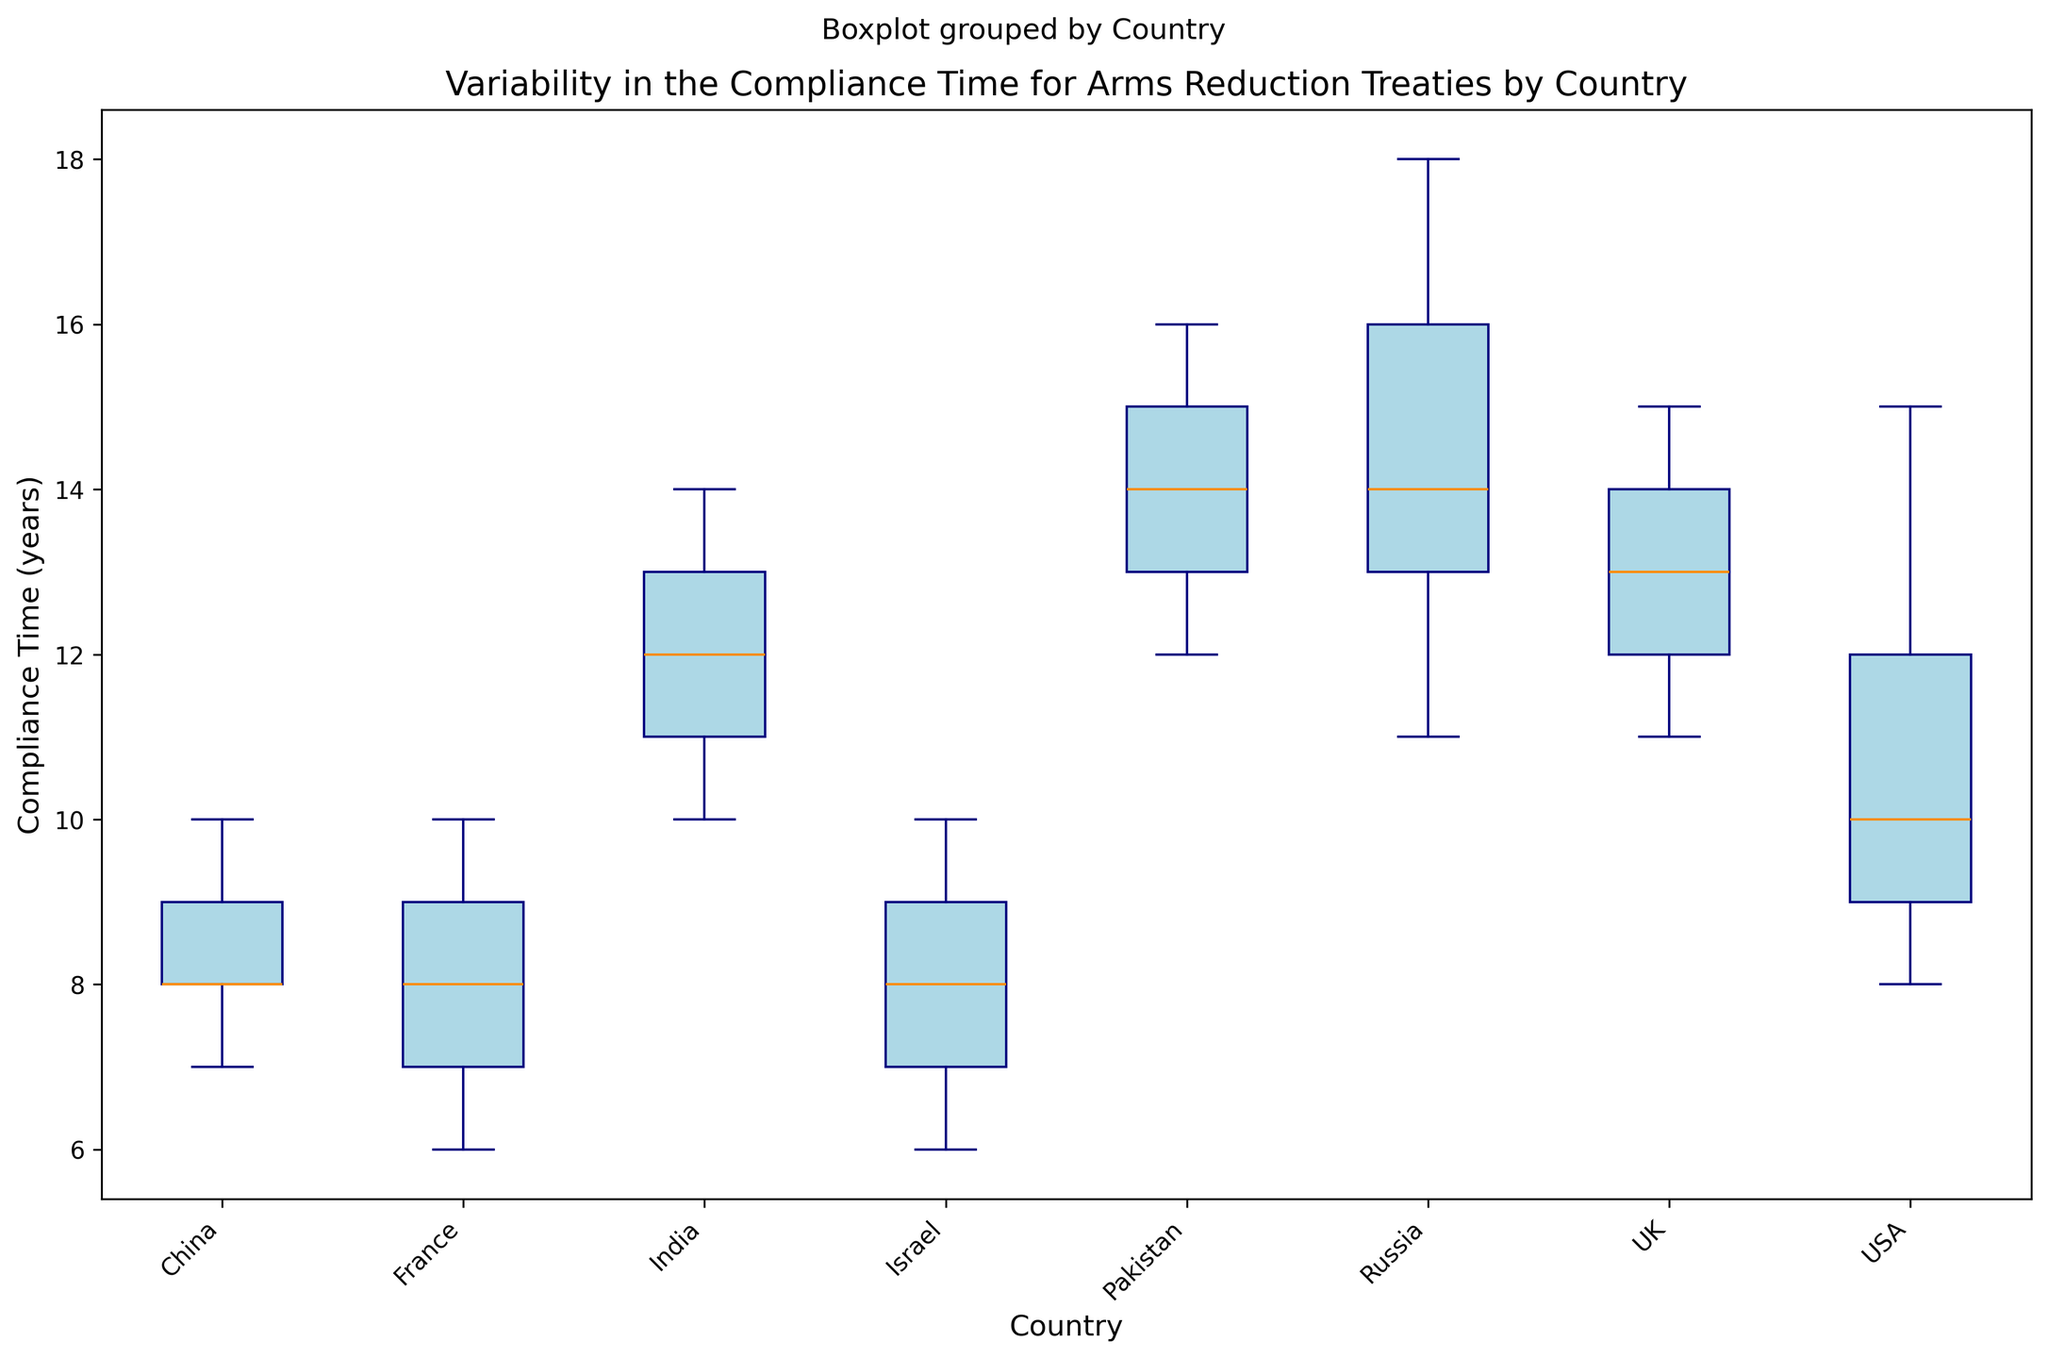What's the median compliance time for China? To find the median compliance time for China, look at the middle value of its sorted compliance times (7, 8, 8, 9, 10). The median is 8.
Answer: 8 Which country has the largest range in compliance time? The range is the difference between the maximum and minimum values. USA (15-8=7), Russia (18-11=7), China (10-7=3), UK (15-11=4), France (10-6=4), India (14-10=4), Pakistan (16-12=4), and Israel (10-6=4). Both USA and Russia have the largest range at 7 years.
Answer: USA and Russia Which country has the smallest interquartile range (IQR)? IQR is the difference between the third quartile (Q3) and the first quartile (Q1). Visually compare the widths of the boxes in the plot. The smallest IQR corresponds to the narrowest box. Israel's box is the narrowest, indicating the smallest IQR.
Answer: Israel What is the median compliance time for the USA compared to France? Identify the median lines in the USA and France boxes. The USA median is around 10 years, while France's is 8 years. The USA has a higher median compliance time.
Answer: USA has a higher median compliance time Describe the variability in compliance time for India's compliance compared to the UK? Observe the whiskers and the spread of the boxes. Both the UK and India have similar ranges and IQR, but India's variability is slightly higher due to whiskers extending a bit more.
Answer: India has slightly higher variability Which countries have outliers in their compliance times? A red marker (outlier) is present in the box of the countries. Visually inspect each box. Only the USA shows outliers.
Answer: USA has outliers On average, is Israel's compliance time lower than China's? Compare the median lines (representing the average) for both countries. Israel’s median (8) is slightly lower than China's (8).
Answer: No Which country has the highest maximum compliance time? Locate the topmost points (whiskers) of each box plot. Russia's box extends to 18, indicating the highest maximum compliance time.
Answer: Russia Does Pakistan have a higher median compliance time compared to India? Compare the median lines of both countries' boxes. Pakistan and India both have median lines around 13, indicating similar median compliance times.
Answer: No, they are similar Whose compliance time is lower, Russia's first quartile (Q1) or the UK's third quartile (Q3)? Locate Russia's Q1 (box bottom) and UK's Q3 (box top). Russia’s Q1 (around 13) is higher than the UK's Q3 (around 14).
Answer: UK's Q3 is higher 